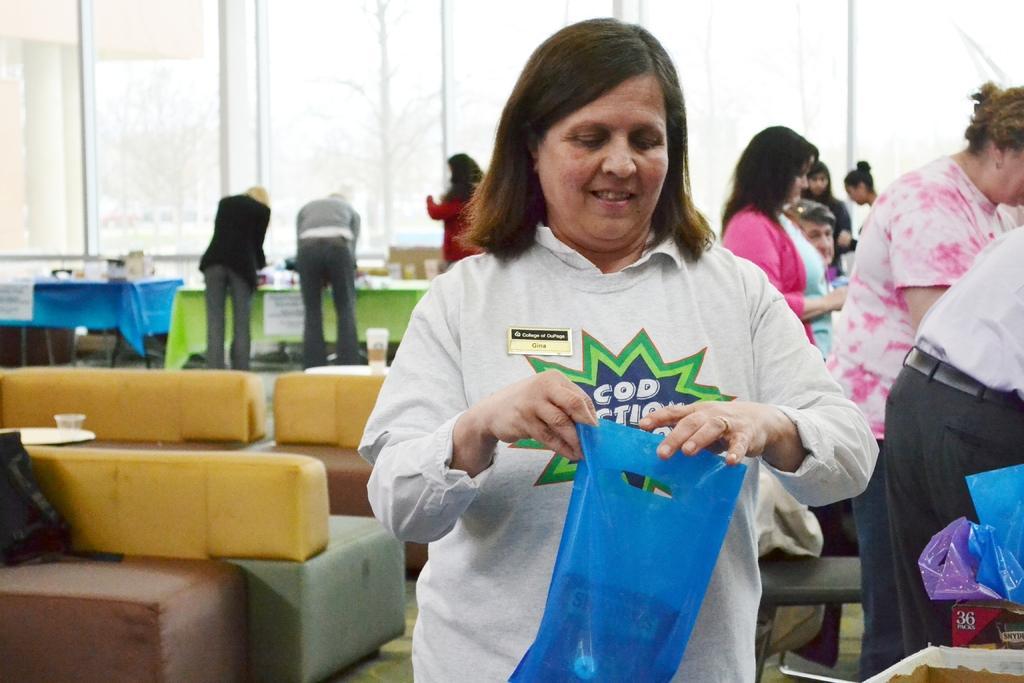How would you summarize this image in a sentence or two? Front this woman is holding a plastic bag. Background we can see people, tables, glass windows, couches, plastic bags and things. To that tables there are posters. 